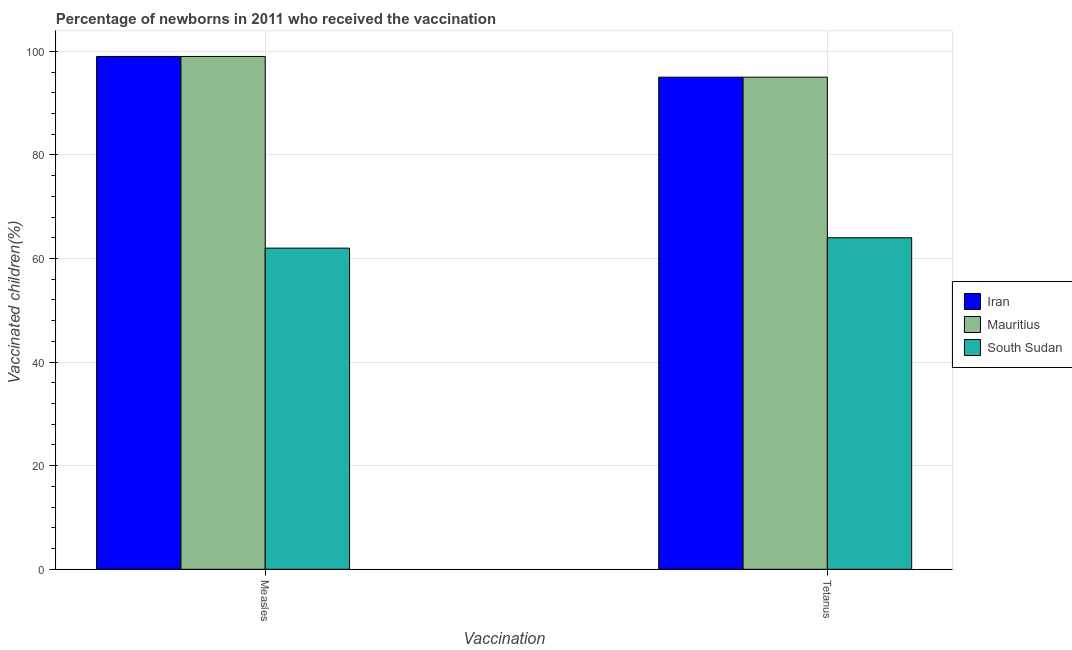How many different coloured bars are there?
Give a very brief answer. 3. How many groups of bars are there?
Your answer should be compact. 2. Are the number of bars per tick equal to the number of legend labels?
Your response must be concise. Yes. What is the label of the 2nd group of bars from the left?
Keep it short and to the point. Tetanus. What is the percentage of newborns who received vaccination for measles in Mauritius?
Offer a terse response. 99. Across all countries, what is the maximum percentage of newborns who received vaccination for measles?
Your response must be concise. 99. Across all countries, what is the minimum percentage of newborns who received vaccination for tetanus?
Give a very brief answer. 64. In which country was the percentage of newborns who received vaccination for measles maximum?
Keep it short and to the point. Iran. In which country was the percentage of newborns who received vaccination for tetanus minimum?
Your response must be concise. South Sudan. What is the total percentage of newborns who received vaccination for tetanus in the graph?
Give a very brief answer. 254. What is the difference between the percentage of newborns who received vaccination for tetanus in Mauritius and that in South Sudan?
Your answer should be compact. 31. What is the difference between the percentage of newborns who received vaccination for tetanus in South Sudan and the percentage of newborns who received vaccination for measles in Iran?
Provide a short and direct response. -35. What is the average percentage of newborns who received vaccination for tetanus per country?
Ensure brevity in your answer.  84.67. What is the difference between the percentage of newborns who received vaccination for tetanus and percentage of newborns who received vaccination for measles in South Sudan?
Make the answer very short. 2. What is the ratio of the percentage of newborns who received vaccination for measles in South Sudan to that in Iran?
Offer a very short reply. 0.63. In how many countries, is the percentage of newborns who received vaccination for measles greater than the average percentage of newborns who received vaccination for measles taken over all countries?
Ensure brevity in your answer.  2. What does the 3rd bar from the left in Measles represents?
Give a very brief answer. South Sudan. What does the 1st bar from the right in Measles represents?
Your answer should be very brief. South Sudan. What is the difference between two consecutive major ticks on the Y-axis?
Offer a very short reply. 20. Does the graph contain grids?
Ensure brevity in your answer.  Yes. Where does the legend appear in the graph?
Offer a very short reply. Center right. How many legend labels are there?
Provide a short and direct response. 3. What is the title of the graph?
Your response must be concise. Percentage of newborns in 2011 who received the vaccination. What is the label or title of the X-axis?
Your answer should be compact. Vaccination. What is the label or title of the Y-axis?
Provide a succinct answer. Vaccinated children(%)
. What is the Vaccinated children(%)
 of Iran in Measles?
Your response must be concise. 99. What is the Vaccinated children(%)
 of Mauritius in Measles?
Your answer should be very brief. 99. What is the Vaccinated children(%)
 in South Sudan in Measles?
Ensure brevity in your answer.  62. What is the Vaccinated children(%)
 in Mauritius in Tetanus?
Ensure brevity in your answer.  95. Across all Vaccination, what is the maximum Vaccinated children(%)
 of Iran?
Make the answer very short. 99. Across all Vaccination, what is the maximum Vaccinated children(%)
 in South Sudan?
Your answer should be very brief. 64. Across all Vaccination, what is the minimum Vaccinated children(%)
 in Iran?
Ensure brevity in your answer.  95. Across all Vaccination, what is the minimum Vaccinated children(%)
 in Mauritius?
Provide a succinct answer. 95. What is the total Vaccinated children(%)
 in Iran in the graph?
Make the answer very short. 194. What is the total Vaccinated children(%)
 of Mauritius in the graph?
Offer a terse response. 194. What is the total Vaccinated children(%)
 in South Sudan in the graph?
Your answer should be very brief. 126. What is the difference between the Vaccinated children(%)
 in Mauritius in Measles and that in Tetanus?
Offer a very short reply. 4. What is the difference between the Vaccinated children(%)
 of South Sudan in Measles and that in Tetanus?
Provide a succinct answer. -2. What is the difference between the Vaccinated children(%)
 in Iran in Measles and the Vaccinated children(%)
 in South Sudan in Tetanus?
Provide a short and direct response. 35. What is the difference between the Vaccinated children(%)
 of Mauritius in Measles and the Vaccinated children(%)
 of South Sudan in Tetanus?
Your answer should be very brief. 35. What is the average Vaccinated children(%)
 of Iran per Vaccination?
Offer a terse response. 97. What is the average Vaccinated children(%)
 in Mauritius per Vaccination?
Keep it short and to the point. 97. What is the difference between the Vaccinated children(%)
 in Iran and Vaccinated children(%)
 in Mauritius in Measles?
Give a very brief answer. 0. What is the difference between the Vaccinated children(%)
 of Mauritius and Vaccinated children(%)
 of South Sudan in Measles?
Make the answer very short. 37. What is the ratio of the Vaccinated children(%)
 of Iran in Measles to that in Tetanus?
Make the answer very short. 1.04. What is the ratio of the Vaccinated children(%)
 of Mauritius in Measles to that in Tetanus?
Your answer should be very brief. 1.04. What is the ratio of the Vaccinated children(%)
 of South Sudan in Measles to that in Tetanus?
Keep it short and to the point. 0.97. What is the difference between the highest and the second highest Vaccinated children(%)
 in Iran?
Make the answer very short. 4. What is the difference between the highest and the second highest Vaccinated children(%)
 in Mauritius?
Ensure brevity in your answer.  4. What is the difference between the highest and the lowest Vaccinated children(%)
 of Iran?
Your answer should be very brief. 4. 